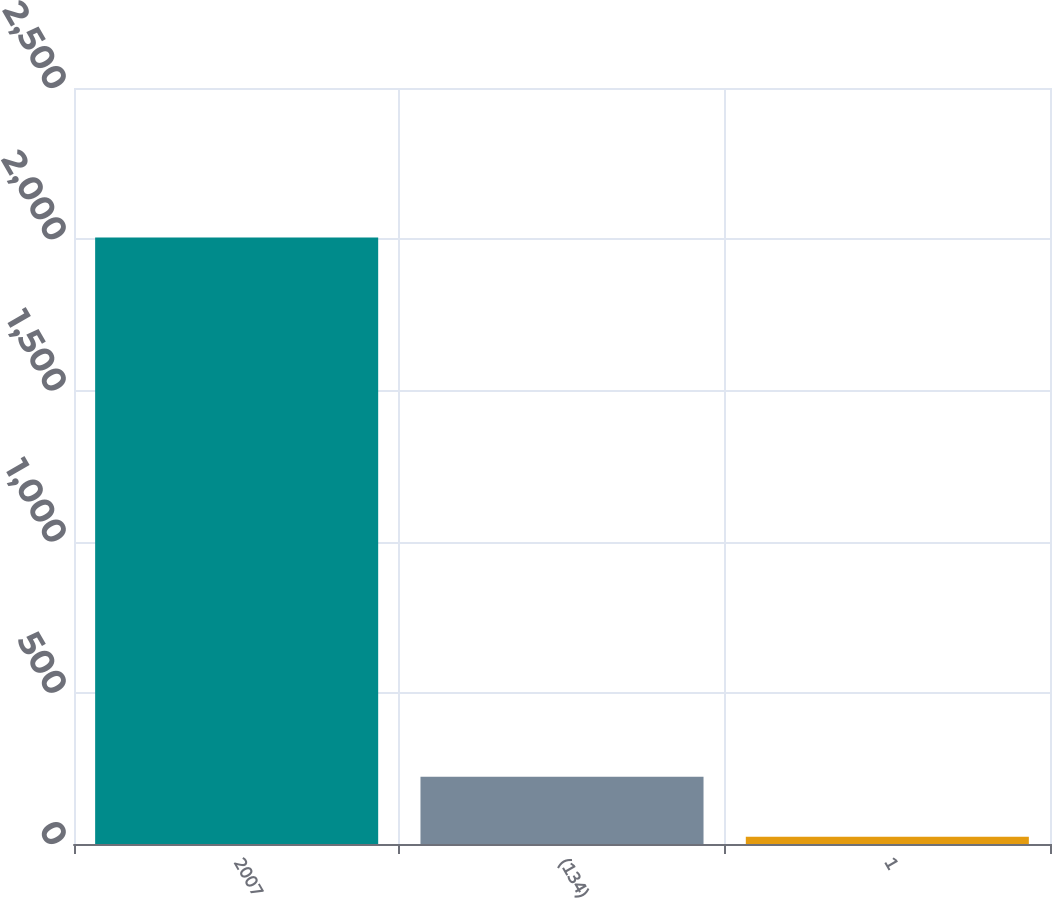Convert chart. <chart><loc_0><loc_0><loc_500><loc_500><bar_chart><fcel>2007<fcel>(134)<fcel>1<nl><fcel>2006<fcel>222.2<fcel>24<nl></chart> 